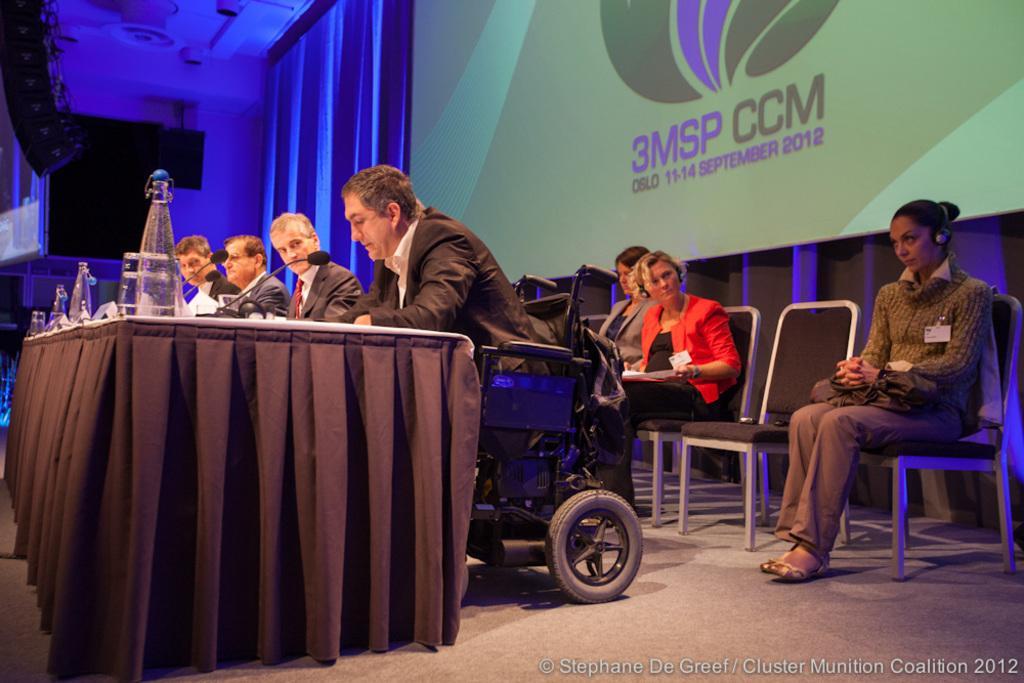How would you summarize this image in a sentence or two? This picture describes about group of people, few are seated on the chairs and a man is seated on the wheelchair, in front of them we can find few bottles, microphones and other things on the table, in the background we can see a projector screen. 